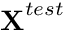Convert formula to latex. <formula><loc_0><loc_0><loc_500><loc_500>X ^ { t e s t }</formula> 